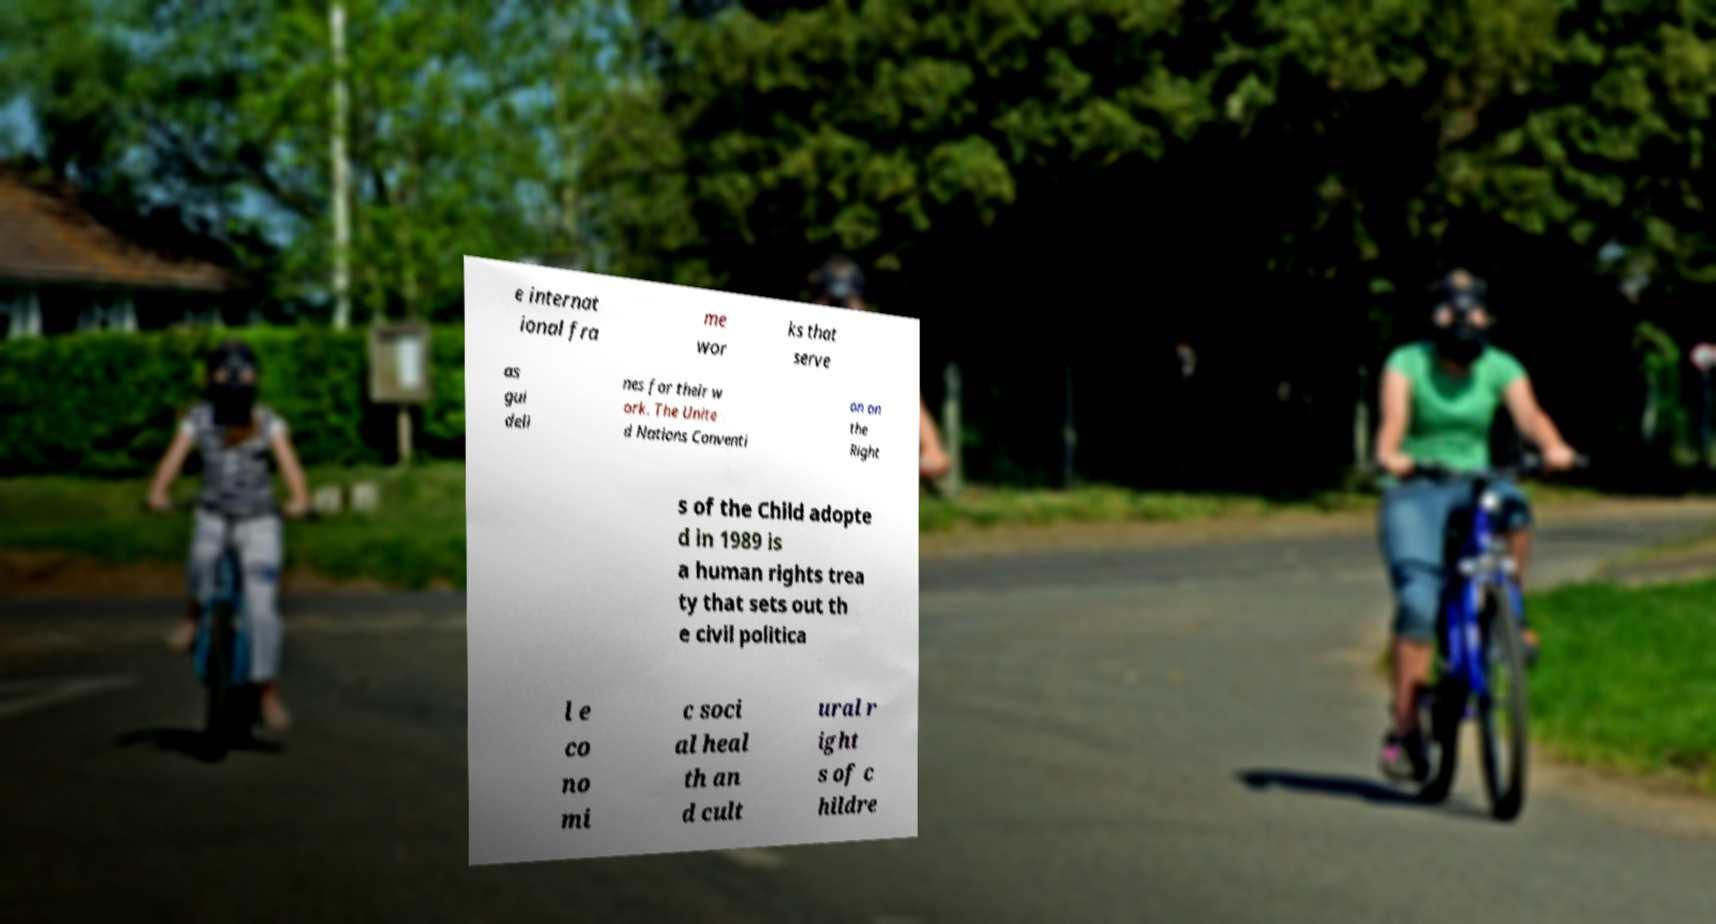For documentation purposes, I need the text within this image transcribed. Could you provide that? e internat ional fra me wor ks that serve as gui deli nes for their w ork. The Unite d Nations Conventi on on the Right s of the Child adopte d in 1989 is a human rights trea ty that sets out th e civil politica l e co no mi c soci al heal th an d cult ural r ight s of c hildre 